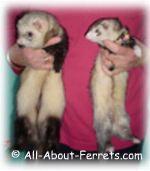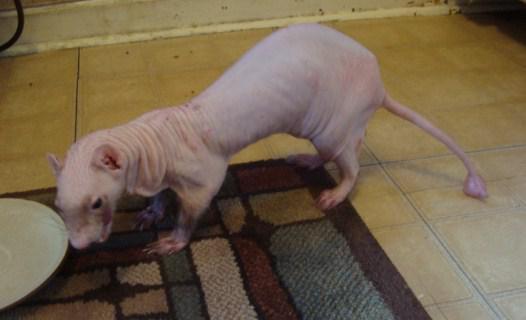The first image is the image on the left, the second image is the image on the right. Assess this claim about the two images: "The left image shows side-by-side ferrets standing on their own feet, and the right image shows a single forward-facing ferret.". Correct or not? Answer yes or no. No. The first image is the image on the left, the second image is the image on the right. For the images shown, is this caption "Two ferrets are standing." true? Answer yes or no. No. 